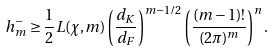Convert formula to latex. <formula><loc_0><loc_0><loc_500><loc_500>h _ { m } ^ { - } \geq \frac { 1 } { 2 } L ( \chi , m ) \left ( \frac { d _ { K } } { d _ { F } } \right ) ^ { m - 1 / 2 } \left ( \frac { ( m - 1 ) ! } { ( 2 \pi ) ^ { m } } \right ) ^ { n } .</formula> 